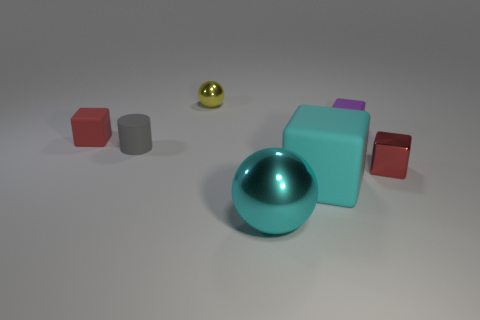Subtract 1 blocks. How many blocks are left? 3 Subtract all yellow blocks. Subtract all yellow cylinders. How many blocks are left? 4 Add 1 big blocks. How many objects exist? 8 Subtract all cubes. How many objects are left? 3 Add 1 tiny purple rubber objects. How many tiny purple rubber objects are left? 2 Add 1 tiny yellow metallic objects. How many tiny yellow metallic objects exist? 2 Subtract 0 blue cylinders. How many objects are left? 7 Subtract all small matte cubes. Subtract all purple blocks. How many objects are left? 4 